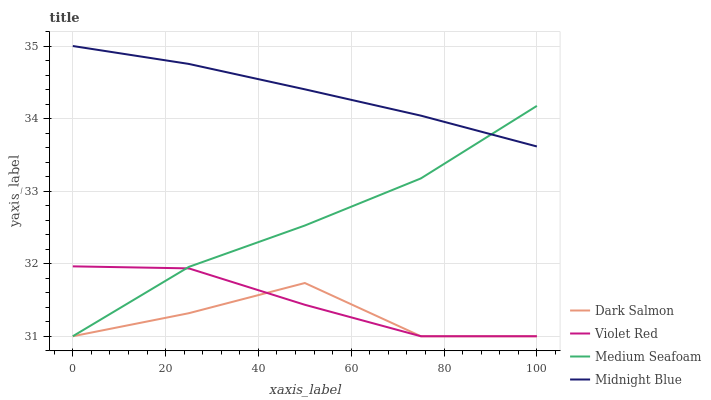Does Dark Salmon have the minimum area under the curve?
Answer yes or no. Yes. Does Midnight Blue have the maximum area under the curve?
Answer yes or no. Yes. Does Midnight Blue have the minimum area under the curve?
Answer yes or no. No. Does Dark Salmon have the maximum area under the curve?
Answer yes or no. No. Is Midnight Blue the smoothest?
Answer yes or no. Yes. Is Dark Salmon the roughest?
Answer yes or no. Yes. Is Dark Salmon the smoothest?
Answer yes or no. No. Is Midnight Blue the roughest?
Answer yes or no. No. Does Violet Red have the lowest value?
Answer yes or no. Yes. Does Midnight Blue have the lowest value?
Answer yes or no. No. Does Midnight Blue have the highest value?
Answer yes or no. Yes. Does Dark Salmon have the highest value?
Answer yes or no. No. Is Violet Red less than Midnight Blue?
Answer yes or no. Yes. Is Midnight Blue greater than Dark Salmon?
Answer yes or no. Yes. Does Midnight Blue intersect Medium Seafoam?
Answer yes or no. Yes. Is Midnight Blue less than Medium Seafoam?
Answer yes or no. No. Is Midnight Blue greater than Medium Seafoam?
Answer yes or no. No. Does Violet Red intersect Midnight Blue?
Answer yes or no. No. 